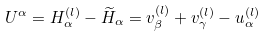<formula> <loc_0><loc_0><loc_500><loc_500>U ^ { \alpha } = H _ { \alpha } ^ { ( l ) } - \widetilde { H } _ { \alpha } = v _ { \beta } ^ { ( l ) } + v _ { \gamma } ^ { ( l ) } - u _ { \alpha } ^ { ( l ) }</formula> 